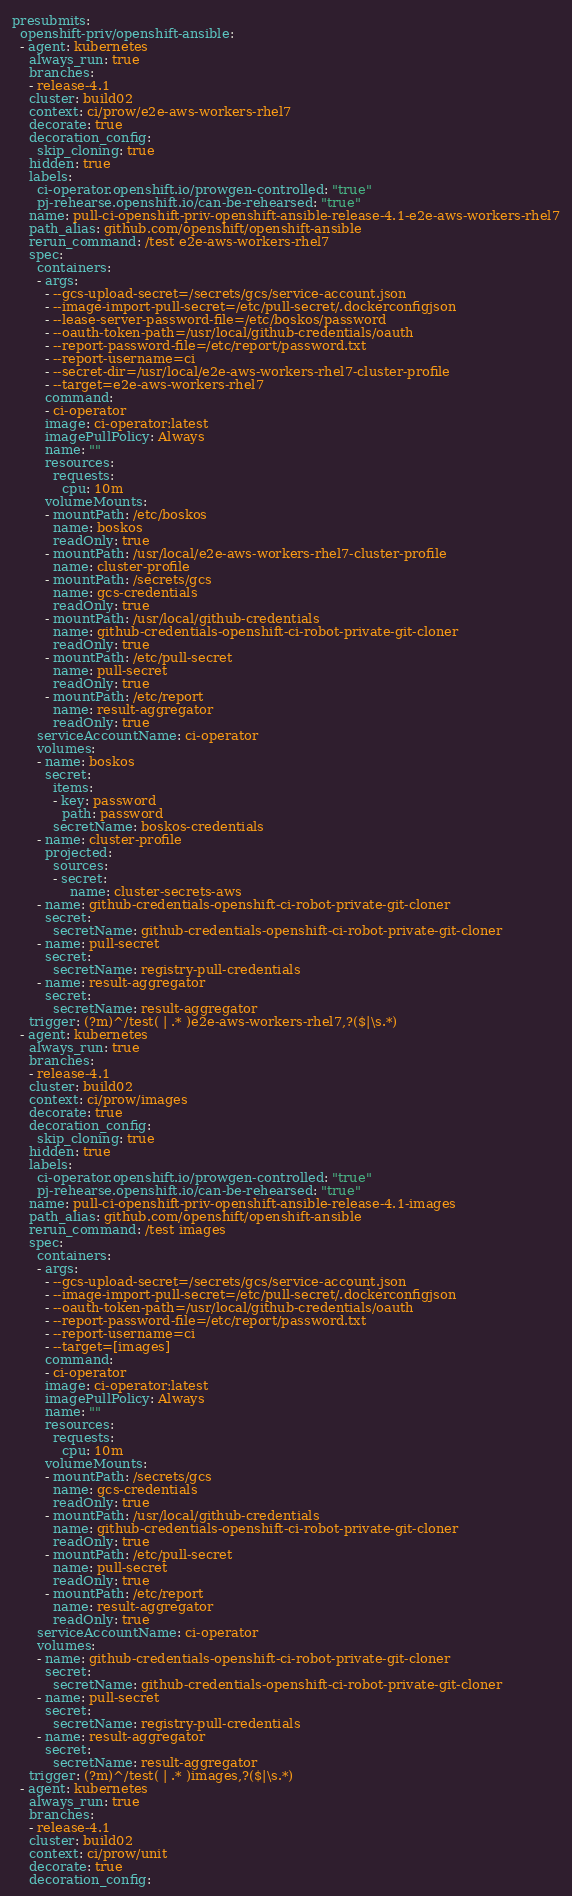Convert code to text. <code><loc_0><loc_0><loc_500><loc_500><_YAML_>presubmits:
  openshift-priv/openshift-ansible:
  - agent: kubernetes
    always_run: true
    branches:
    - release-4.1
    cluster: build02
    context: ci/prow/e2e-aws-workers-rhel7
    decorate: true
    decoration_config:
      skip_cloning: true
    hidden: true
    labels:
      ci-operator.openshift.io/prowgen-controlled: "true"
      pj-rehearse.openshift.io/can-be-rehearsed: "true"
    name: pull-ci-openshift-priv-openshift-ansible-release-4.1-e2e-aws-workers-rhel7
    path_alias: github.com/openshift/openshift-ansible
    rerun_command: /test e2e-aws-workers-rhel7
    spec:
      containers:
      - args:
        - --gcs-upload-secret=/secrets/gcs/service-account.json
        - --image-import-pull-secret=/etc/pull-secret/.dockerconfigjson
        - --lease-server-password-file=/etc/boskos/password
        - --oauth-token-path=/usr/local/github-credentials/oauth
        - --report-password-file=/etc/report/password.txt
        - --report-username=ci
        - --secret-dir=/usr/local/e2e-aws-workers-rhel7-cluster-profile
        - --target=e2e-aws-workers-rhel7
        command:
        - ci-operator
        image: ci-operator:latest
        imagePullPolicy: Always
        name: ""
        resources:
          requests:
            cpu: 10m
        volumeMounts:
        - mountPath: /etc/boskos
          name: boskos
          readOnly: true
        - mountPath: /usr/local/e2e-aws-workers-rhel7-cluster-profile
          name: cluster-profile
        - mountPath: /secrets/gcs
          name: gcs-credentials
          readOnly: true
        - mountPath: /usr/local/github-credentials
          name: github-credentials-openshift-ci-robot-private-git-cloner
          readOnly: true
        - mountPath: /etc/pull-secret
          name: pull-secret
          readOnly: true
        - mountPath: /etc/report
          name: result-aggregator
          readOnly: true
      serviceAccountName: ci-operator
      volumes:
      - name: boskos
        secret:
          items:
          - key: password
            path: password
          secretName: boskos-credentials
      - name: cluster-profile
        projected:
          sources:
          - secret:
              name: cluster-secrets-aws
      - name: github-credentials-openshift-ci-robot-private-git-cloner
        secret:
          secretName: github-credentials-openshift-ci-robot-private-git-cloner
      - name: pull-secret
        secret:
          secretName: registry-pull-credentials
      - name: result-aggregator
        secret:
          secretName: result-aggregator
    trigger: (?m)^/test( | .* )e2e-aws-workers-rhel7,?($|\s.*)
  - agent: kubernetes
    always_run: true
    branches:
    - release-4.1
    cluster: build02
    context: ci/prow/images
    decorate: true
    decoration_config:
      skip_cloning: true
    hidden: true
    labels:
      ci-operator.openshift.io/prowgen-controlled: "true"
      pj-rehearse.openshift.io/can-be-rehearsed: "true"
    name: pull-ci-openshift-priv-openshift-ansible-release-4.1-images
    path_alias: github.com/openshift/openshift-ansible
    rerun_command: /test images
    spec:
      containers:
      - args:
        - --gcs-upload-secret=/secrets/gcs/service-account.json
        - --image-import-pull-secret=/etc/pull-secret/.dockerconfigjson
        - --oauth-token-path=/usr/local/github-credentials/oauth
        - --report-password-file=/etc/report/password.txt
        - --report-username=ci
        - --target=[images]
        command:
        - ci-operator
        image: ci-operator:latest
        imagePullPolicy: Always
        name: ""
        resources:
          requests:
            cpu: 10m
        volumeMounts:
        - mountPath: /secrets/gcs
          name: gcs-credentials
          readOnly: true
        - mountPath: /usr/local/github-credentials
          name: github-credentials-openshift-ci-robot-private-git-cloner
          readOnly: true
        - mountPath: /etc/pull-secret
          name: pull-secret
          readOnly: true
        - mountPath: /etc/report
          name: result-aggregator
          readOnly: true
      serviceAccountName: ci-operator
      volumes:
      - name: github-credentials-openshift-ci-robot-private-git-cloner
        secret:
          secretName: github-credentials-openshift-ci-robot-private-git-cloner
      - name: pull-secret
        secret:
          secretName: registry-pull-credentials
      - name: result-aggregator
        secret:
          secretName: result-aggregator
    trigger: (?m)^/test( | .* )images,?($|\s.*)
  - agent: kubernetes
    always_run: true
    branches:
    - release-4.1
    cluster: build02
    context: ci/prow/unit
    decorate: true
    decoration_config:</code> 